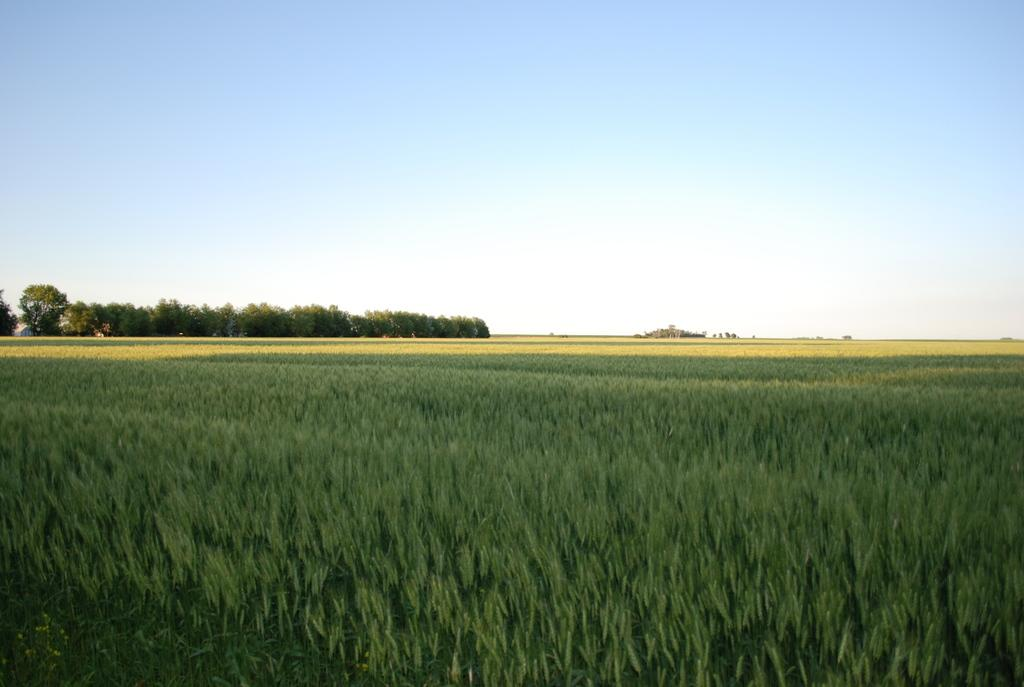What type of landscape is depicted in the image? There are paddy fields in the image. What can be seen on the left side of the image? Trees are present on the left side of the image. What is visible in the background of the image? The sky is visible in the image. What type of dress is the paddy field wearing in the image? Paddy fields do not wear dresses; they are a type of agricultural land used for growing rice. 